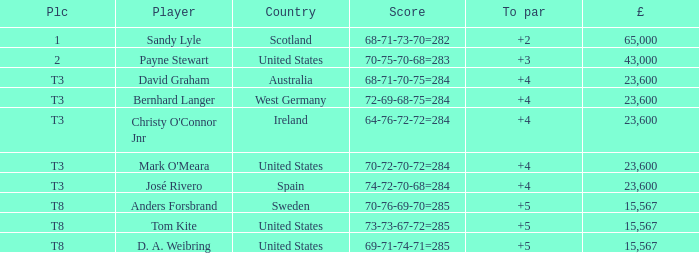Could you parse the entire table as a dict? {'header': ['Plc', 'Player', 'Country', 'Score', 'To par', '£'], 'rows': [['1', 'Sandy Lyle', 'Scotland', '68-71-73-70=282', '+2', '65,000'], ['2', 'Payne Stewart', 'United States', '70-75-70-68=283', '+3', '43,000'], ['T3', 'David Graham', 'Australia', '68-71-70-75=284', '+4', '23,600'], ['T3', 'Bernhard Langer', 'West Germany', '72-69-68-75=284', '+4', '23,600'], ['T3', "Christy O'Connor Jnr", 'Ireland', '64-76-72-72=284', '+4', '23,600'], ['T3', "Mark O'Meara", 'United States', '70-72-70-72=284', '+4', '23,600'], ['T3', 'José Rivero', 'Spain', '74-72-70-68=284', '+4', '23,600'], ['T8', 'Anders Forsbrand', 'Sweden', '70-76-69-70=285', '+5', '15,567'], ['T8', 'Tom Kite', 'United States', '73-73-67-72=285', '+5', '15,567'], ['T8', 'D. A. Weibring', 'United States', '69-71-74-71=285', '+5', '15,567']]} What place is David Graham in? T3. 